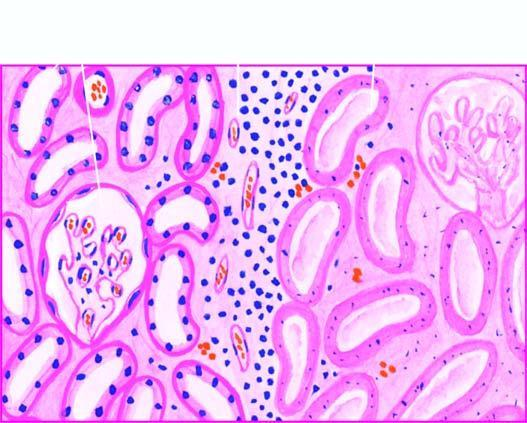what do the nuclei show?
Answer the question using a single word or phrase. Granular debris 